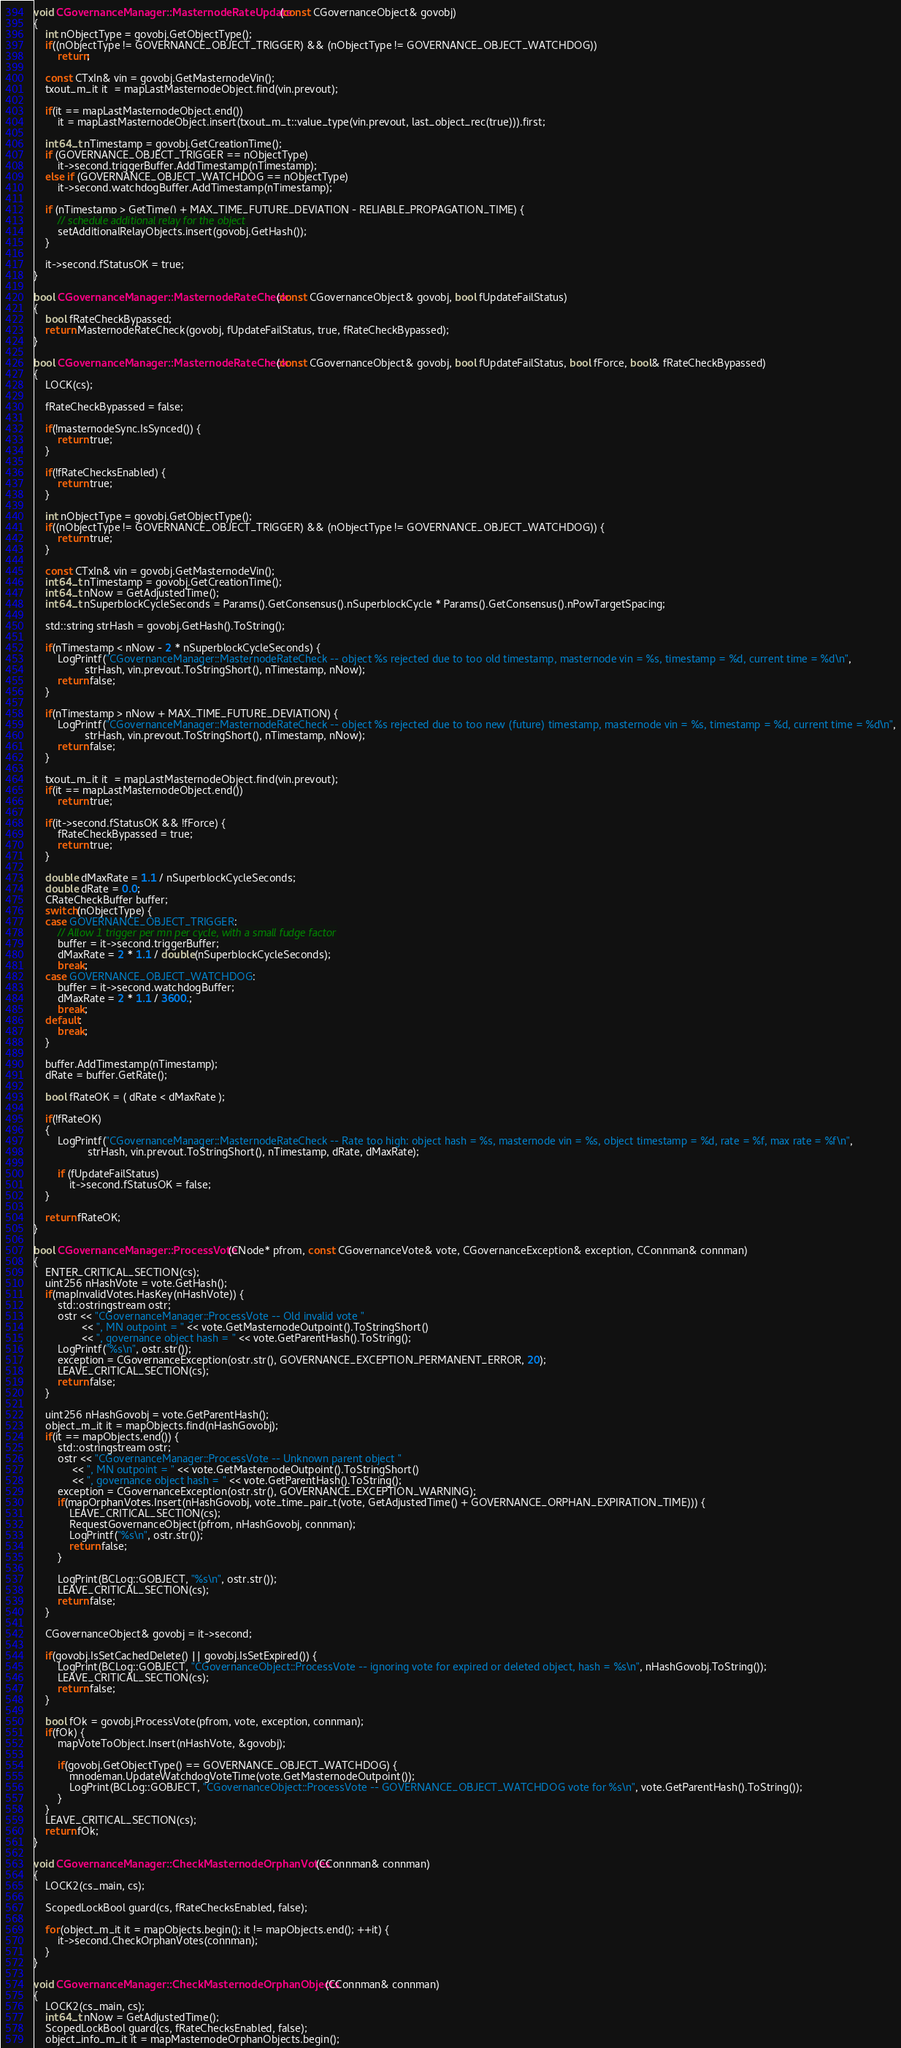<code> <loc_0><loc_0><loc_500><loc_500><_C++_>

void CGovernanceManager::MasternodeRateUpdate(const CGovernanceObject& govobj)
{
    int nObjectType = govobj.GetObjectType();
    if((nObjectType != GOVERNANCE_OBJECT_TRIGGER) && (nObjectType != GOVERNANCE_OBJECT_WATCHDOG))
        return;

    const CTxIn& vin = govobj.GetMasternodeVin();
    txout_m_it it  = mapLastMasternodeObject.find(vin.prevout);

    if(it == mapLastMasternodeObject.end())
        it = mapLastMasternodeObject.insert(txout_m_t::value_type(vin.prevout, last_object_rec(true))).first;

    int64_t nTimestamp = govobj.GetCreationTime();
    if (GOVERNANCE_OBJECT_TRIGGER == nObjectType)
        it->second.triggerBuffer.AddTimestamp(nTimestamp);
    else if (GOVERNANCE_OBJECT_WATCHDOG == nObjectType)
        it->second.watchdogBuffer.AddTimestamp(nTimestamp);

    if (nTimestamp > GetTime() + MAX_TIME_FUTURE_DEVIATION - RELIABLE_PROPAGATION_TIME) {
        // schedule additional relay for the object
        setAdditionalRelayObjects.insert(govobj.GetHash());
    }

    it->second.fStatusOK = true;
}

bool CGovernanceManager::MasternodeRateCheck(const CGovernanceObject& govobj, bool fUpdateFailStatus)
{
    bool fRateCheckBypassed;
    return MasternodeRateCheck(govobj, fUpdateFailStatus, true, fRateCheckBypassed);
}

bool CGovernanceManager::MasternodeRateCheck(const CGovernanceObject& govobj, bool fUpdateFailStatus, bool fForce, bool& fRateCheckBypassed)
{
    LOCK(cs);

    fRateCheckBypassed = false;

    if(!masternodeSync.IsSynced()) {
        return true;
    }

    if(!fRateChecksEnabled) {
        return true;
    }

    int nObjectType = govobj.GetObjectType();
    if((nObjectType != GOVERNANCE_OBJECT_TRIGGER) && (nObjectType != GOVERNANCE_OBJECT_WATCHDOG)) {
        return true;
    }

    const CTxIn& vin = govobj.GetMasternodeVin();
    int64_t nTimestamp = govobj.GetCreationTime();
    int64_t nNow = GetAdjustedTime();
    int64_t nSuperblockCycleSeconds = Params().GetConsensus().nSuperblockCycle * Params().GetConsensus().nPowTargetSpacing;

    std::string strHash = govobj.GetHash().ToString();

    if(nTimestamp < nNow - 2 * nSuperblockCycleSeconds) {
        LogPrintf("CGovernanceManager::MasternodeRateCheck -- object %s rejected due to too old timestamp, masternode vin = %s, timestamp = %d, current time = %d\n",
                 strHash, vin.prevout.ToStringShort(), nTimestamp, nNow);
        return false;
    }

    if(nTimestamp > nNow + MAX_TIME_FUTURE_DEVIATION) {
        LogPrintf("CGovernanceManager::MasternodeRateCheck -- object %s rejected due to too new (future) timestamp, masternode vin = %s, timestamp = %d, current time = %d\n",
                 strHash, vin.prevout.ToStringShort(), nTimestamp, nNow);
        return false;
    }

    txout_m_it it  = mapLastMasternodeObject.find(vin.prevout);
    if(it == mapLastMasternodeObject.end())
        return true;

    if(it->second.fStatusOK && !fForce) {
        fRateCheckBypassed = true;
        return true;
    }

    double dMaxRate = 1.1 / nSuperblockCycleSeconds;
    double dRate = 0.0;
    CRateCheckBuffer buffer;
    switch(nObjectType) {
    case GOVERNANCE_OBJECT_TRIGGER:
        // Allow 1 trigger per mn per cycle, with a small fudge factor
        buffer = it->second.triggerBuffer;
        dMaxRate = 2 * 1.1 / double(nSuperblockCycleSeconds);
        break;
    case GOVERNANCE_OBJECT_WATCHDOG:
        buffer = it->second.watchdogBuffer;
        dMaxRate = 2 * 1.1 / 3600.;
        break;
    default:
        break;
    }

    buffer.AddTimestamp(nTimestamp);
    dRate = buffer.GetRate();

    bool fRateOK = ( dRate < dMaxRate );

    if(!fRateOK)
    {
        LogPrintf("CGovernanceManager::MasternodeRateCheck -- Rate too high: object hash = %s, masternode vin = %s, object timestamp = %d, rate = %f, max rate = %f\n",
                  strHash, vin.prevout.ToStringShort(), nTimestamp, dRate, dMaxRate);

        if (fUpdateFailStatus)
            it->second.fStatusOK = false;
    }

    return fRateOK;
}

bool CGovernanceManager::ProcessVote(CNode* pfrom, const CGovernanceVote& vote, CGovernanceException& exception, CConnman& connman)
{
    ENTER_CRITICAL_SECTION(cs);
    uint256 nHashVote = vote.GetHash();
    if(mapInvalidVotes.HasKey(nHashVote)) {
        std::ostringstream ostr;
        ostr << "CGovernanceManager::ProcessVote -- Old invalid vote "
                << ", MN outpoint = " << vote.GetMasternodeOutpoint().ToStringShort()
                << ", governance object hash = " << vote.GetParentHash().ToString();
        LogPrintf("%s\n", ostr.str());
        exception = CGovernanceException(ostr.str(), GOVERNANCE_EXCEPTION_PERMANENT_ERROR, 20);
        LEAVE_CRITICAL_SECTION(cs);
        return false;
    }

    uint256 nHashGovobj = vote.GetParentHash();
    object_m_it it = mapObjects.find(nHashGovobj);
    if(it == mapObjects.end()) {
        std::ostringstream ostr;
        ostr << "CGovernanceManager::ProcessVote -- Unknown parent object "
             << ", MN outpoint = " << vote.GetMasternodeOutpoint().ToStringShort()
             << ", governance object hash = " << vote.GetParentHash().ToString();
        exception = CGovernanceException(ostr.str(), GOVERNANCE_EXCEPTION_WARNING);
        if(mapOrphanVotes.Insert(nHashGovobj, vote_time_pair_t(vote, GetAdjustedTime() + GOVERNANCE_ORPHAN_EXPIRATION_TIME))) {
            LEAVE_CRITICAL_SECTION(cs);
            RequestGovernanceObject(pfrom, nHashGovobj, connman);
            LogPrintf("%s\n", ostr.str());
            return false;
        }

        LogPrint(BCLog::GOBJECT, "%s\n", ostr.str());
        LEAVE_CRITICAL_SECTION(cs);
        return false;
    }

    CGovernanceObject& govobj = it->second;

    if(govobj.IsSetCachedDelete() || govobj.IsSetExpired()) {
        LogPrint(BCLog::GOBJECT, "CGovernanceObject::ProcessVote -- ignoring vote for expired or deleted object, hash = %s\n", nHashGovobj.ToString());
        LEAVE_CRITICAL_SECTION(cs);
        return false;
    }

    bool fOk = govobj.ProcessVote(pfrom, vote, exception, connman);
    if(fOk) {
        mapVoteToObject.Insert(nHashVote, &govobj);

        if(govobj.GetObjectType() == GOVERNANCE_OBJECT_WATCHDOG) {
            mnodeman.UpdateWatchdogVoteTime(vote.GetMasternodeOutpoint());
            LogPrint(BCLog::GOBJECT, "CGovernanceObject::ProcessVote -- GOVERNANCE_OBJECT_WATCHDOG vote for %s\n", vote.GetParentHash().ToString());
        }
    }
    LEAVE_CRITICAL_SECTION(cs);
    return fOk;
}

void CGovernanceManager::CheckMasternodeOrphanVotes(CConnman& connman)
{
    LOCK2(cs_main, cs);

    ScopedLockBool guard(cs, fRateChecksEnabled, false);

    for(object_m_it it = mapObjects.begin(); it != mapObjects.end(); ++it) {
        it->second.CheckOrphanVotes(connman);
    }
}

void CGovernanceManager::CheckMasternodeOrphanObjects(CConnman& connman)
{
    LOCK2(cs_main, cs);
    int64_t nNow = GetAdjustedTime();
    ScopedLockBool guard(cs, fRateChecksEnabled, false);
    object_info_m_it it = mapMasternodeOrphanObjects.begin();</code> 